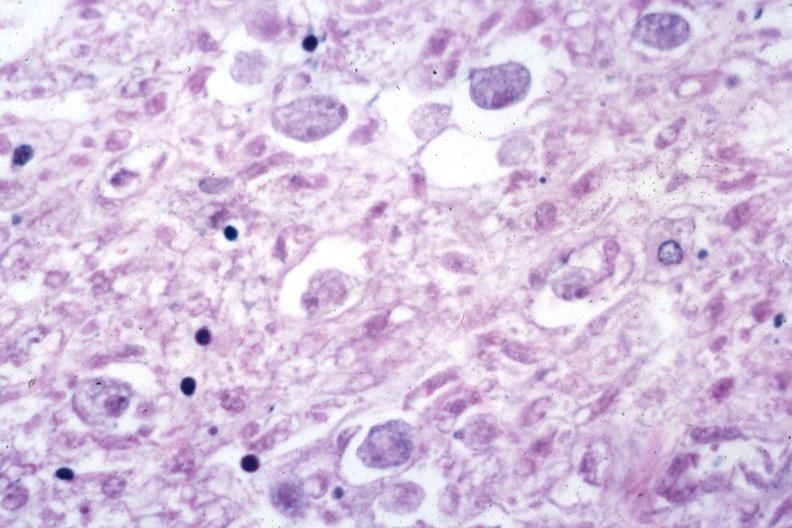what is present?
Answer the question using a single word or phrase. Colon 